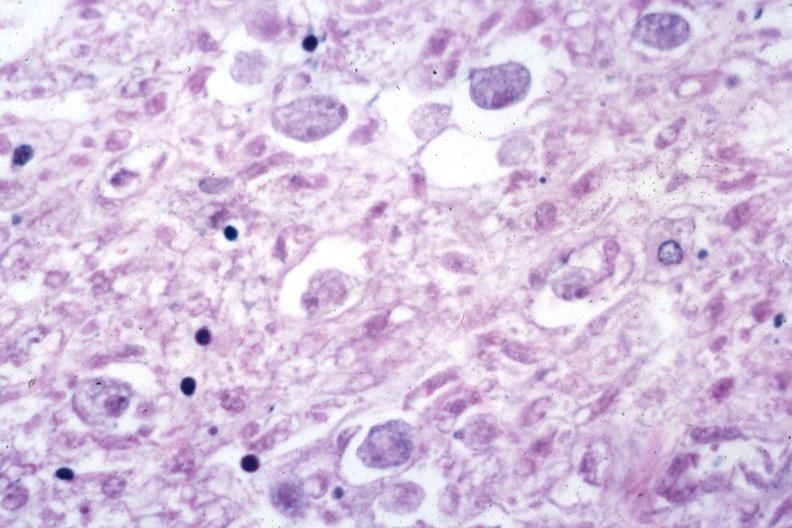what is present?
Answer the question using a single word or phrase. Colon 